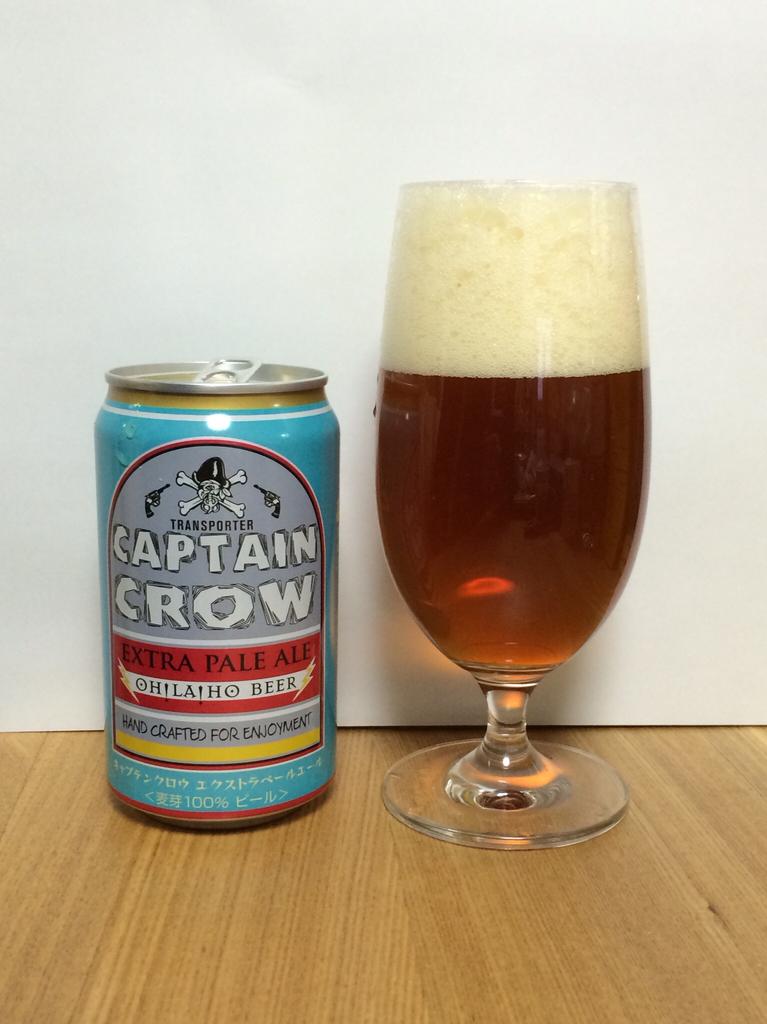What is the brand of the beer?
Keep it short and to the point. Captain crow. What kind of beer is this?
Your answer should be compact. Captain crow. 